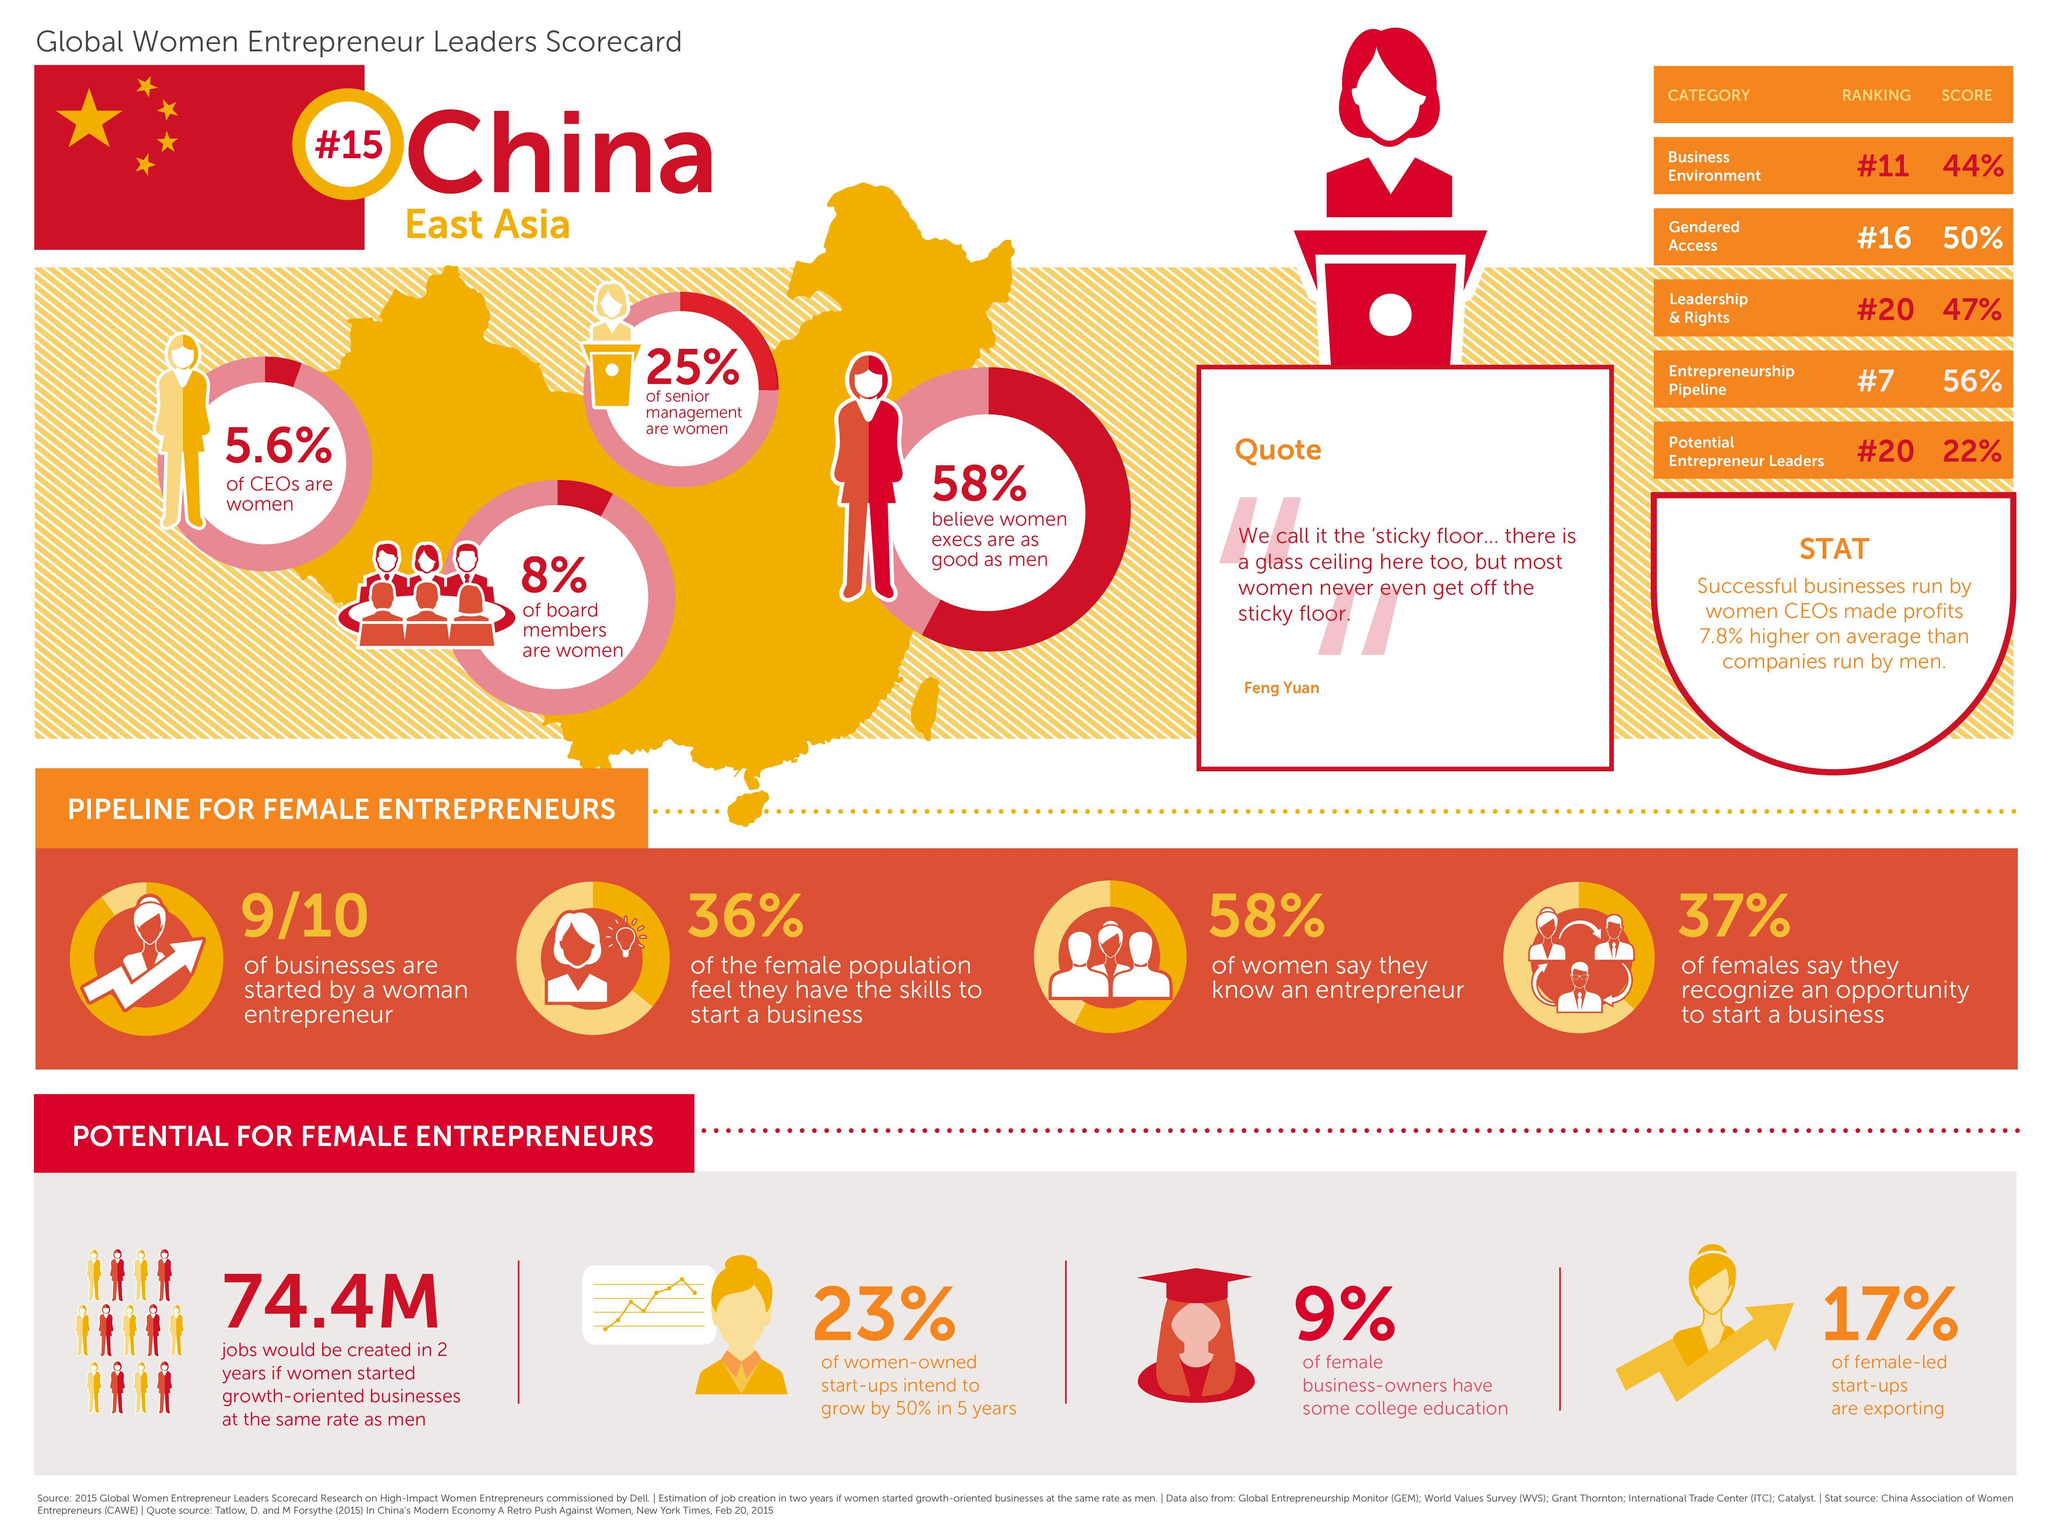What percent of women feel they are skilled to set up a business?
Answer the question with a short phrase. 36% What percent of women-led startups are exporting? 17% How many of the businesses are launched by a woman entrepreneur? 9/10 What percent of women-owned startups intend to grow by 50% in 5 years? 23% What percent of the women entrepreneurs have college education? 9% How many of the women say they can identify a business opportunity? 37% What percent of people believe that women executives are as good as men? 58% 